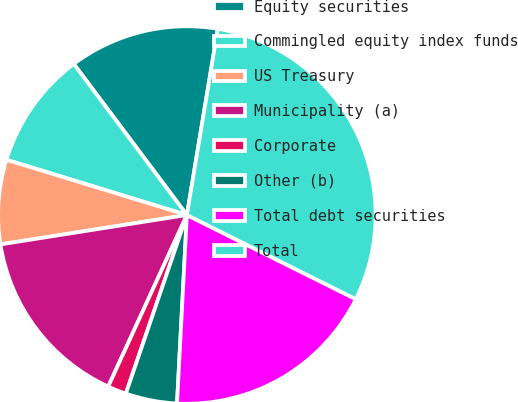Convert chart. <chart><loc_0><loc_0><loc_500><loc_500><pie_chart><fcel>Equity securities<fcel>Commingled equity index funds<fcel>US Treasury<fcel>Municipality (a)<fcel>Corporate<fcel>Other (b)<fcel>Total debt securities<fcel>Total<nl><fcel>12.85%<fcel>10.04%<fcel>7.22%<fcel>15.67%<fcel>1.6%<fcel>4.41%<fcel>18.48%<fcel>29.74%<nl></chart> 